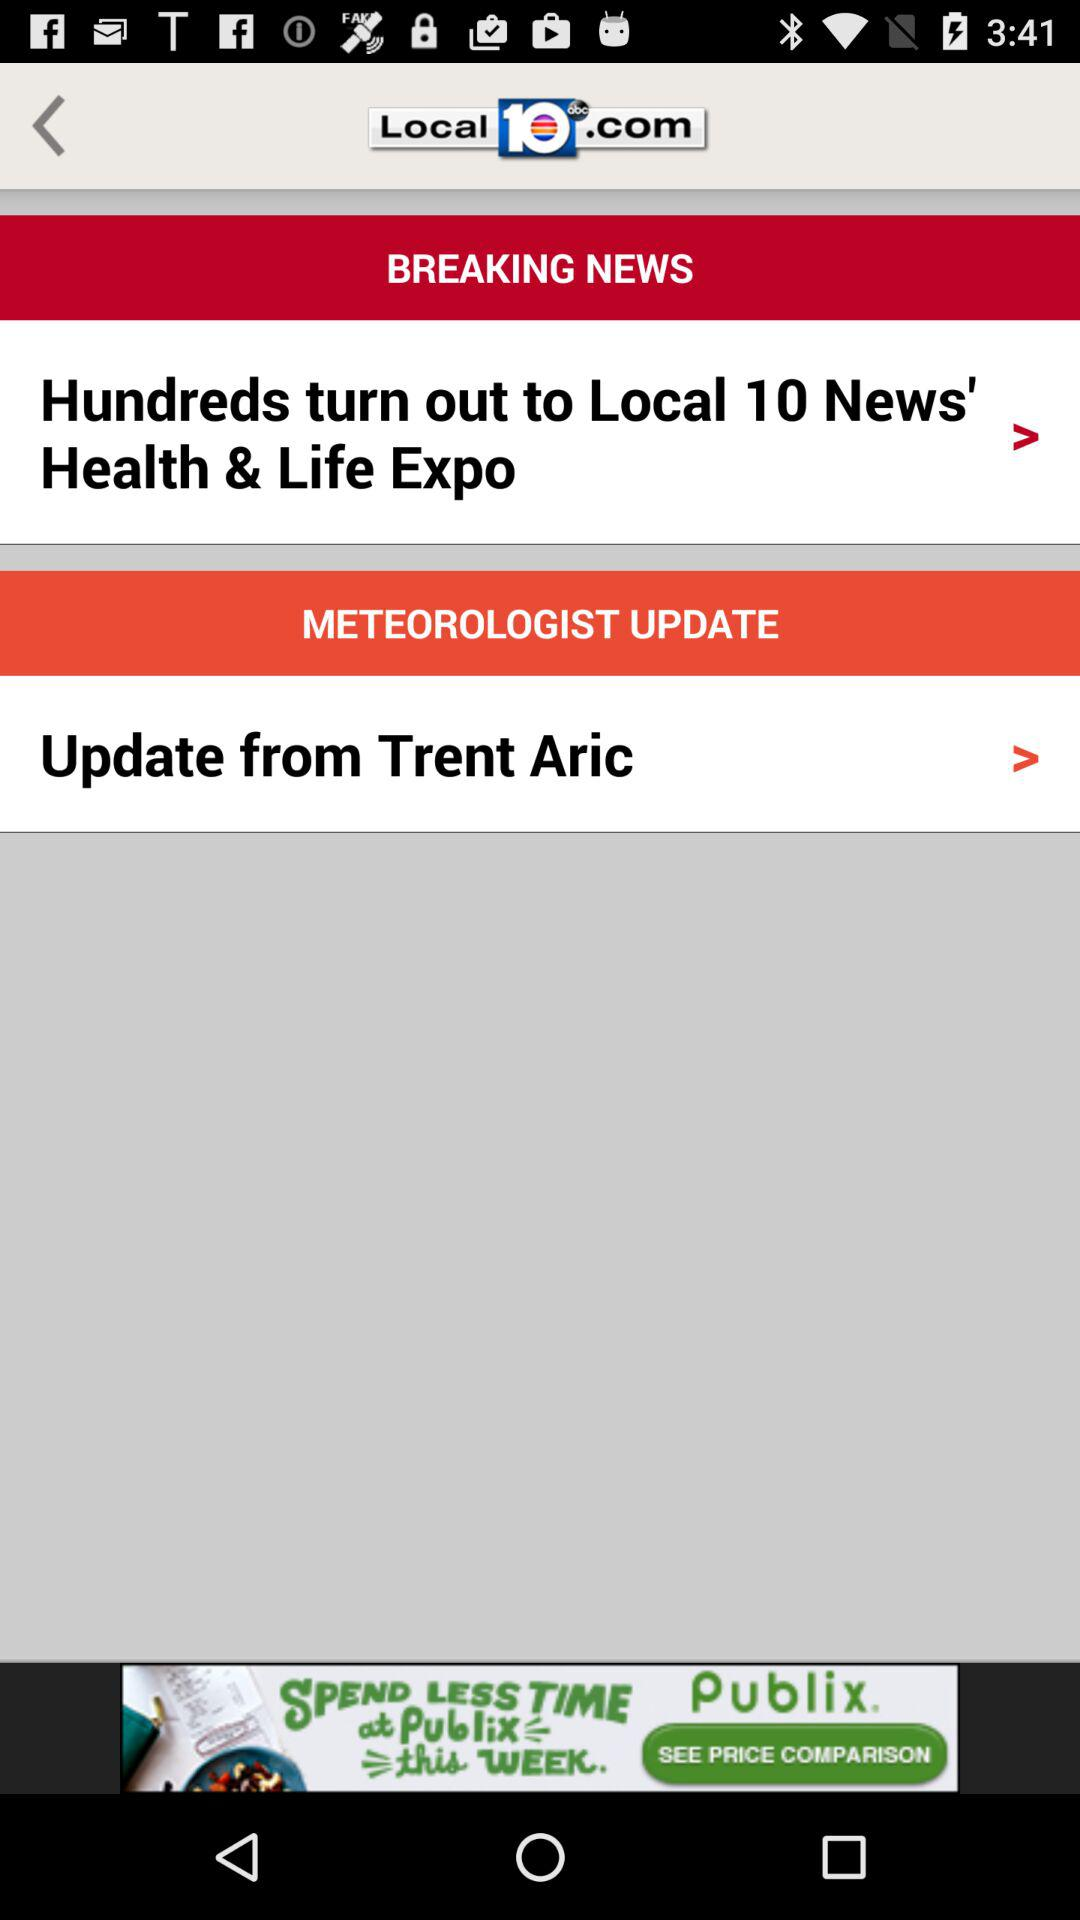What is the name of the application? The name of the application is "Local 10 abc.com". 